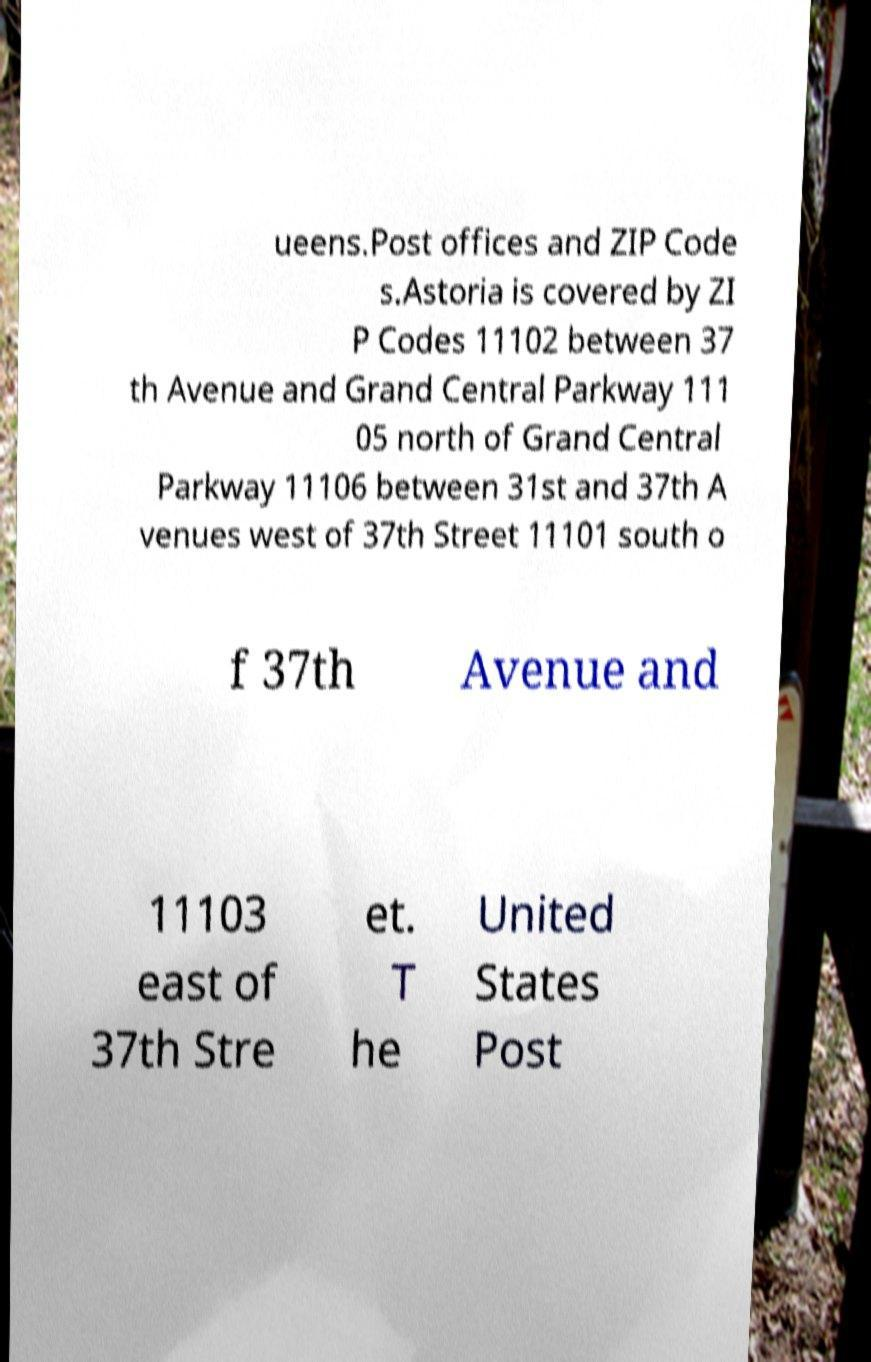I need the written content from this picture converted into text. Can you do that? ueens.Post offices and ZIP Code s.Astoria is covered by ZI P Codes 11102 between 37 th Avenue and Grand Central Parkway 111 05 north of Grand Central Parkway 11106 between 31st and 37th A venues west of 37th Street 11101 south o f 37th Avenue and 11103 east of 37th Stre et. T he United States Post 